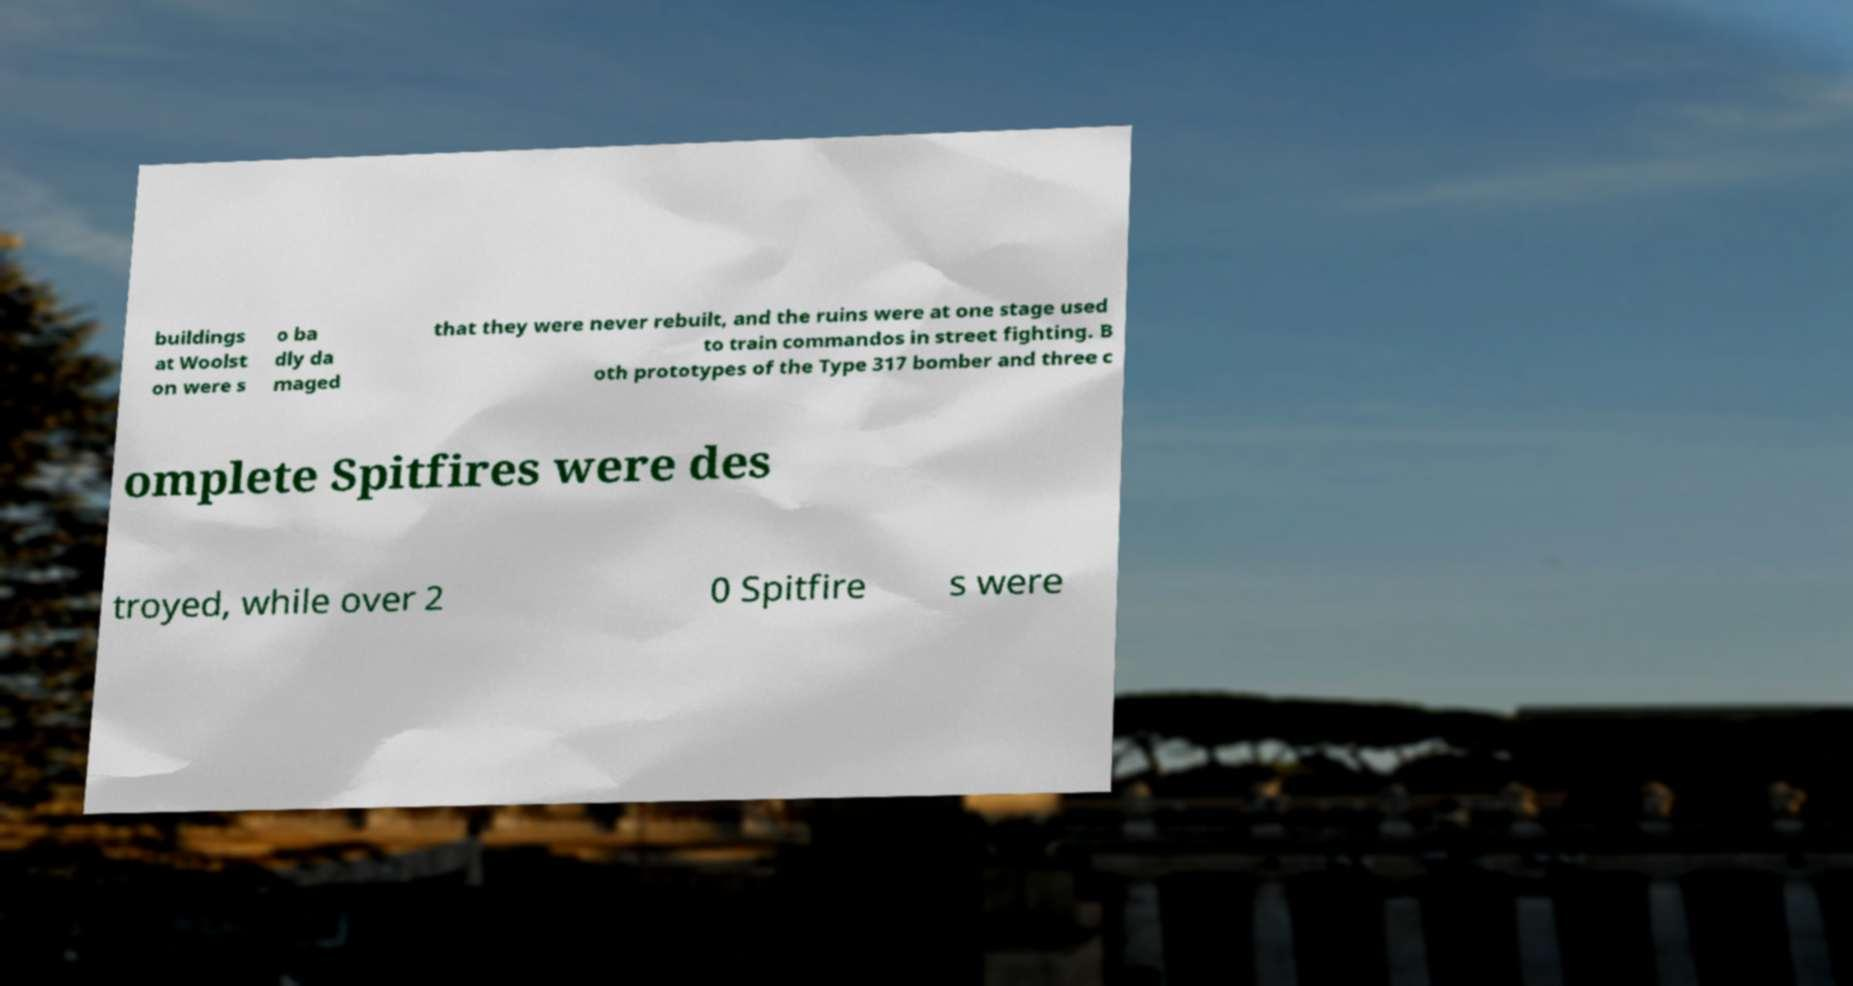Could you extract and type out the text from this image? buildings at Woolst on were s o ba dly da maged that they were never rebuilt, and the ruins were at one stage used to train commandos in street fighting. B oth prototypes of the Type 317 bomber and three c omplete Spitfires were des troyed, while over 2 0 Spitfire s were 